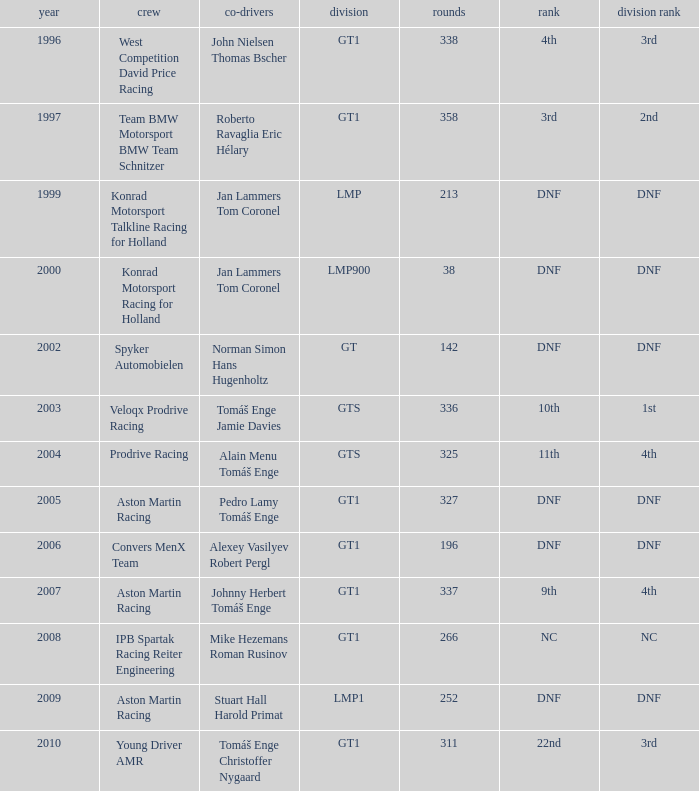What was the position in 1997? 3rd. 